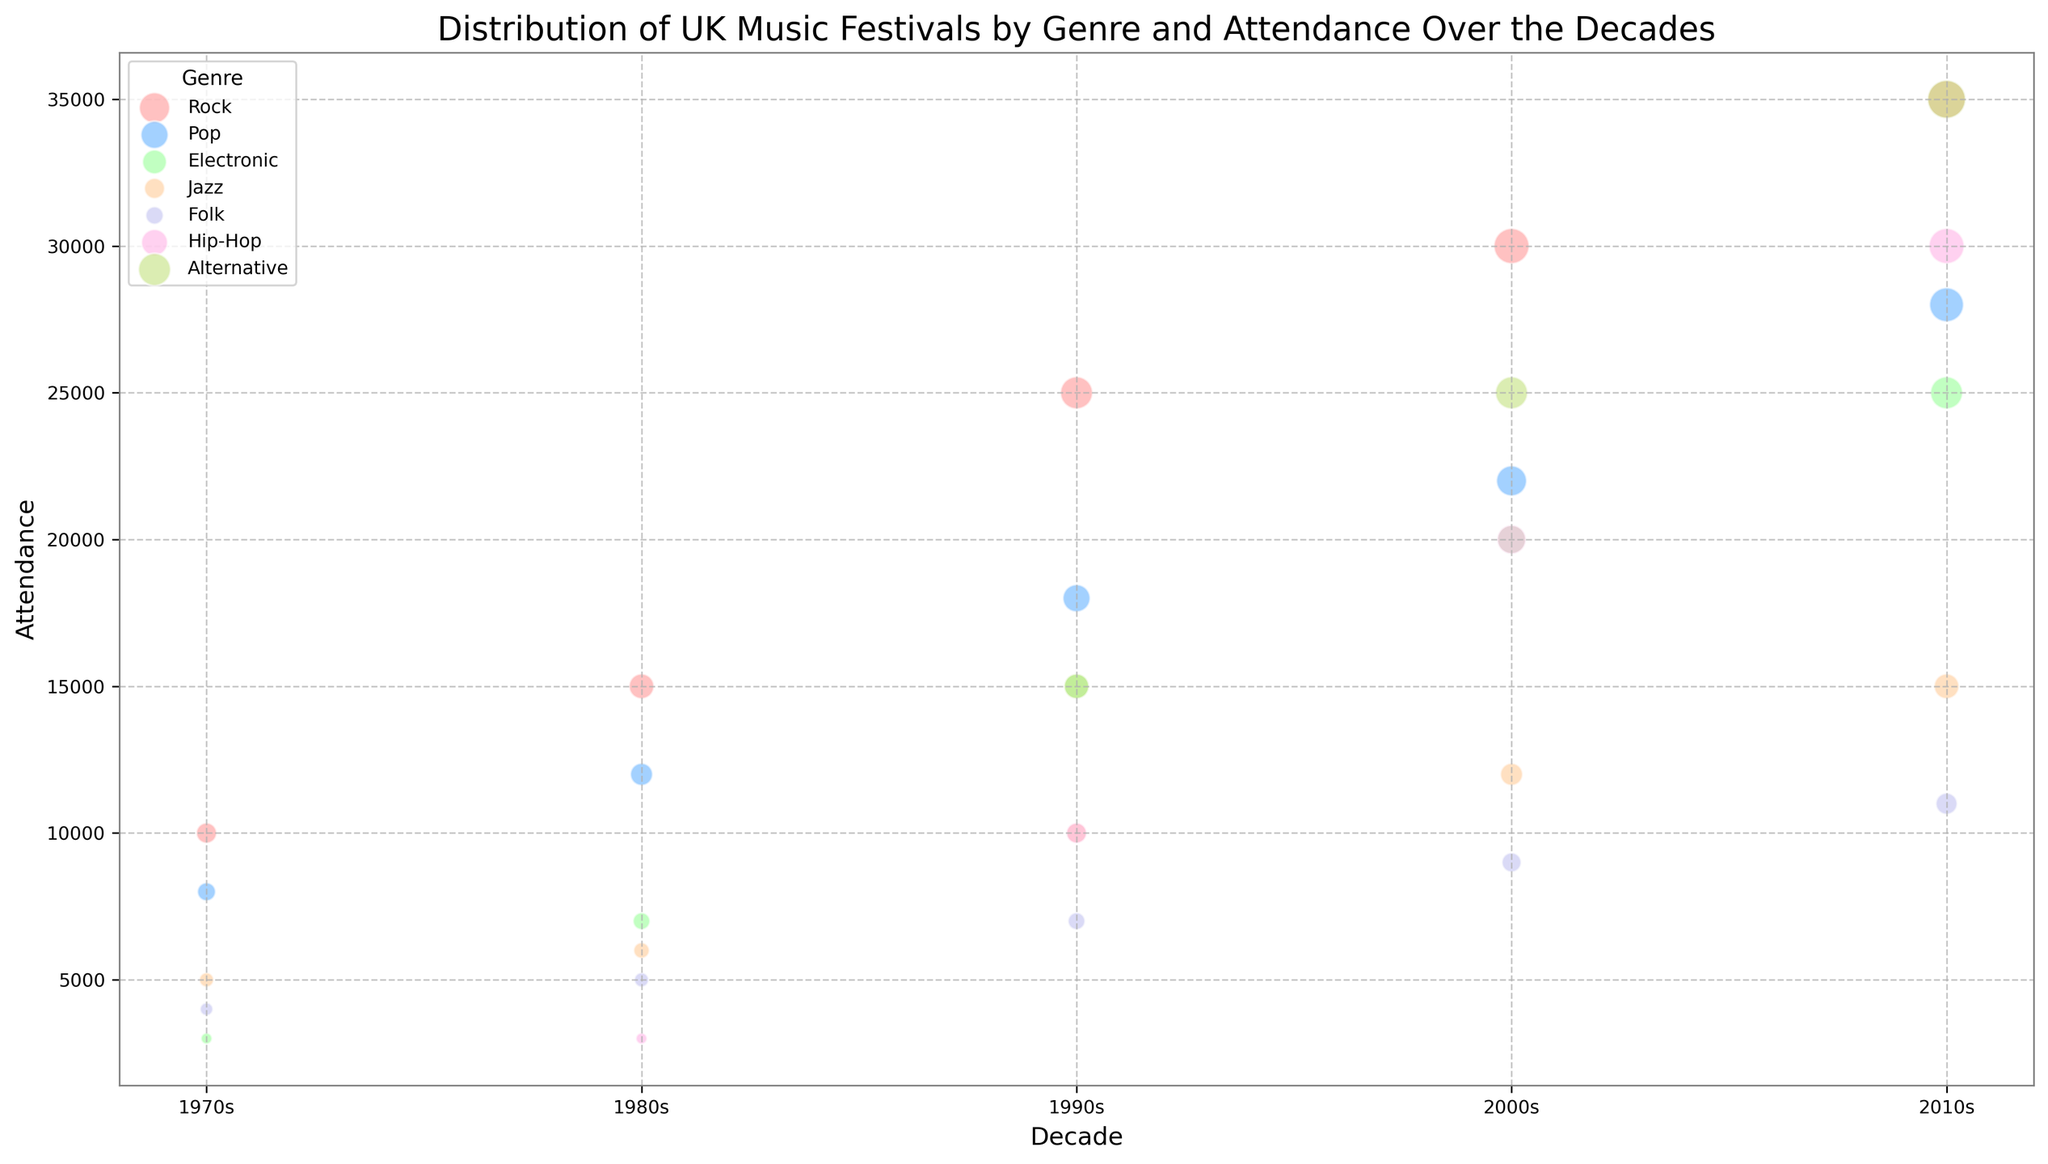Which genre had the highest attendance in the 2010s? First, locate the 2010s on the x-axis. Then, identify the genre with the largest bubble size corresponding to that decade.
Answer: Rock Which decade saw the largest growth in attendance for Jazz festivals? Identify the decade with the steepest increase in bubble size for Jazz by checking successive bubbles' sizes. The largest growth occurs where the difference in size is the greatest.
Answer: 1990s Which genre had more attendees in the 1980s, Electronic or Folk? Look at the 1980s on the x-axis and compare the bubble sizes/colors for Electronic and Folk.
Answer: Electronic Compare the attendance growth of Pop and Hip-Hop festivals between the 1990s and 2010s. Which grew more? Calculate the difference in attendance from the 1990s to the 2010s for each genre: Pop (28000 - 18000 = 10000) and Hip-Hop (30000 - 10000 = 20000). Hip-Hop had a larger growth.
Answer: Hip-Hop grew more How did the attendance of Rock festivals in the 2000s compare to that of Alternative festivals in the same decade? Compare the two bubble sizes for Rock and Alternative in the 2000s directly.
Answer: Rock had a higher attendance Which genre maintained relatively constant attendance across the decades? Look for a genre whose bubble sizes do not vary greatly across different decades.
Answer: Folk What is the difference in attendance between the largest and smallest genres in the 1990s? Identify the largest and smallest bubbles in the 1990s. The largest is Rock (25000) and the smallest is Folk (7000). Subtracting 7000 from 25000 gives the difference.
Answer: 18000 In which decade did Electronic music festivals experience the sharpest increase in attendance? Determine the decade with the largest increase in bubble size for Electronic by comparing consecutive decades.
Answer: 1990s How do the attendance figures for Rock festivals in the 1970s and 2010s compare to the total attendance for Folk across all decades? Sum the attendance of Folk across all decades (4000 + 5000 + 7000 + 9000 + 11000 = 36000). The combined attendance for Rock in the 1970s and 2010s is 45000. Compare these totals.
Answer: Rock is higher by 9000 Which genre saw a debut on the chart in the 1980s and what was the attendance? Find the genre that first appears in the 1980s. Hip-Hop is the genre with an attendance of 3000.
Answer: Hip-Hop, 3000 